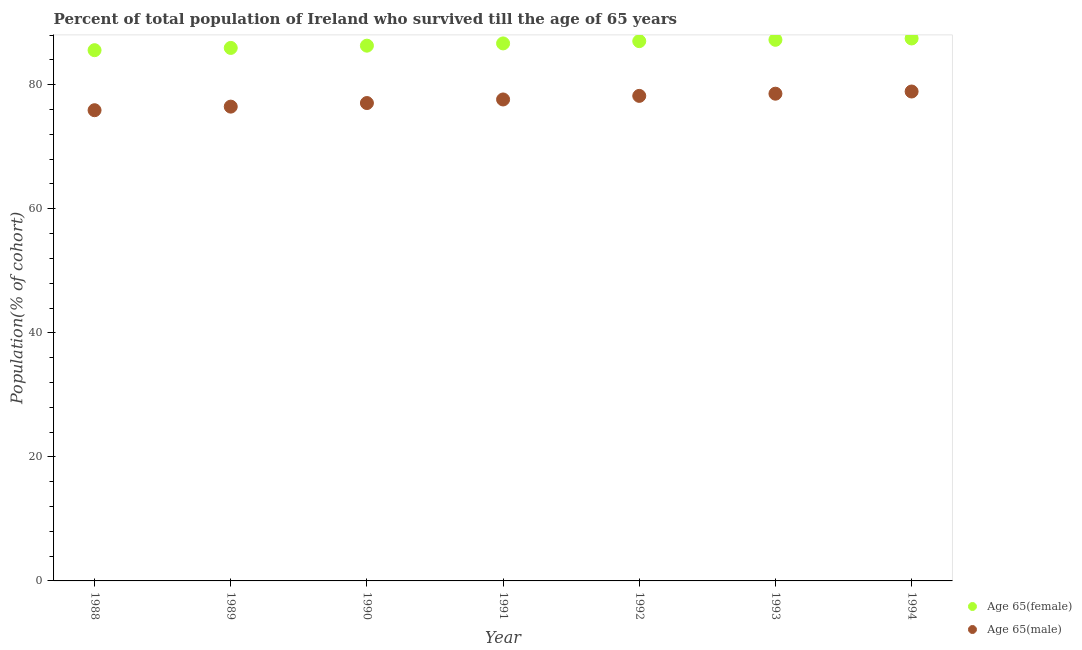How many different coloured dotlines are there?
Ensure brevity in your answer.  2. What is the percentage of male population who survived till age of 65 in 1991?
Provide a succinct answer. 77.62. Across all years, what is the maximum percentage of male population who survived till age of 65?
Provide a succinct answer. 78.9. Across all years, what is the minimum percentage of female population who survived till age of 65?
Keep it short and to the point. 85.57. In which year was the percentage of female population who survived till age of 65 maximum?
Make the answer very short. 1994. What is the total percentage of female population who survived till age of 65 in the graph?
Provide a short and direct response. 606.17. What is the difference between the percentage of female population who survived till age of 65 in 1988 and that in 1993?
Give a very brief answer. -1.67. What is the difference between the percentage of female population who survived till age of 65 in 1990 and the percentage of male population who survived till age of 65 in 1991?
Ensure brevity in your answer.  8.67. What is the average percentage of female population who survived till age of 65 per year?
Offer a terse response. 86.6. In the year 1989, what is the difference between the percentage of female population who survived till age of 65 and percentage of male population who survived till age of 65?
Your answer should be compact. 9.46. In how many years, is the percentage of female population who survived till age of 65 greater than 16 %?
Keep it short and to the point. 7. What is the ratio of the percentage of female population who survived till age of 65 in 1993 to that in 1994?
Ensure brevity in your answer.  1. What is the difference between the highest and the second highest percentage of female population who survived till age of 65?
Give a very brief answer. 0.22. What is the difference between the highest and the lowest percentage of male population who survived till age of 65?
Make the answer very short. 3.02. In how many years, is the percentage of male population who survived till age of 65 greater than the average percentage of male population who survived till age of 65 taken over all years?
Your answer should be compact. 4. Does the percentage of male population who survived till age of 65 monotonically increase over the years?
Make the answer very short. Yes. Is the percentage of female population who survived till age of 65 strictly less than the percentage of male population who survived till age of 65 over the years?
Make the answer very short. No. How many years are there in the graph?
Your response must be concise. 7. Does the graph contain any zero values?
Offer a terse response. No. Where does the legend appear in the graph?
Give a very brief answer. Bottom right. How many legend labels are there?
Give a very brief answer. 2. How are the legend labels stacked?
Your answer should be compact. Vertical. What is the title of the graph?
Your answer should be very brief. Percent of total population of Ireland who survived till the age of 65 years. What is the label or title of the Y-axis?
Ensure brevity in your answer.  Population(% of cohort). What is the Population(% of cohort) of Age 65(female) in 1988?
Make the answer very short. 85.57. What is the Population(% of cohort) in Age 65(male) in 1988?
Keep it short and to the point. 75.89. What is the Population(% of cohort) of Age 65(female) in 1989?
Ensure brevity in your answer.  85.93. What is the Population(% of cohort) of Age 65(male) in 1989?
Your answer should be very brief. 76.47. What is the Population(% of cohort) of Age 65(female) in 1990?
Offer a terse response. 86.29. What is the Population(% of cohort) of Age 65(male) in 1990?
Give a very brief answer. 77.04. What is the Population(% of cohort) in Age 65(female) in 1991?
Your answer should be compact. 86.66. What is the Population(% of cohort) of Age 65(male) in 1991?
Provide a short and direct response. 77.62. What is the Population(% of cohort) in Age 65(female) in 1992?
Provide a short and direct response. 87.02. What is the Population(% of cohort) in Age 65(male) in 1992?
Your response must be concise. 78.2. What is the Population(% of cohort) in Age 65(female) in 1993?
Offer a terse response. 87.24. What is the Population(% of cohort) of Age 65(male) in 1993?
Give a very brief answer. 78.55. What is the Population(% of cohort) in Age 65(female) in 1994?
Your answer should be compact. 87.46. What is the Population(% of cohort) in Age 65(male) in 1994?
Keep it short and to the point. 78.9. Across all years, what is the maximum Population(% of cohort) in Age 65(female)?
Offer a very short reply. 87.46. Across all years, what is the maximum Population(% of cohort) in Age 65(male)?
Offer a terse response. 78.9. Across all years, what is the minimum Population(% of cohort) of Age 65(female)?
Provide a succinct answer. 85.57. Across all years, what is the minimum Population(% of cohort) in Age 65(male)?
Provide a succinct answer. 75.89. What is the total Population(% of cohort) in Age 65(female) in the graph?
Offer a terse response. 606.17. What is the total Population(% of cohort) in Age 65(male) in the graph?
Your response must be concise. 542.67. What is the difference between the Population(% of cohort) in Age 65(female) in 1988 and that in 1989?
Your answer should be compact. -0.36. What is the difference between the Population(% of cohort) in Age 65(male) in 1988 and that in 1989?
Offer a very short reply. -0.58. What is the difference between the Population(% of cohort) of Age 65(female) in 1988 and that in 1990?
Provide a succinct answer. -0.73. What is the difference between the Population(% of cohort) in Age 65(male) in 1988 and that in 1990?
Provide a short and direct response. -1.16. What is the difference between the Population(% of cohort) of Age 65(female) in 1988 and that in 1991?
Offer a terse response. -1.09. What is the difference between the Population(% of cohort) of Age 65(male) in 1988 and that in 1991?
Keep it short and to the point. -1.73. What is the difference between the Population(% of cohort) of Age 65(female) in 1988 and that in 1992?
Give a very brief answer. -1.46. What is the difference between the Population(% of cohort) in Age 65(male) in 1988 and that in 1992?
Offer a terse response. -2.31. What is the difference between the Population(% of cohort) of Age 65(female) in 1988 and that in 1993?
Your answer should be very brief. -1.67. What is the difference between the Population(% of cohort) in Age 65(male) in 1988 and that in 1993?
Offer a very short reply. -2.66. What is the difference between the Population(% of cohort) of Age 65(female) in 1988 and that in 1994?
Provide a succinct answer. -1.89. What is the difference between the Population(% of cohort) in Age 65(male) in 1988 and that in 1994?
Give a very brief answer. -3.02. What is the difference between the Population(% of cohort) of Age 65(female) in 1989 and that in 1990?
Your response must be concise. -0.36. What is the difference between the Population(% of cohort) in Age 65(male) in 1989 and that in 1990?
Ensure brevity in your answer.  -0.58. What is the difference between the Population(% of cohort) of Age 65(female) in 1989 and that in 1991?
Your answer should be compact. -0.73. What is the difference between the Population(% of cohort) of Age 65(male) in 1989 and that in 1991?
Your response must be concise. -1.16. What is the difference between the Population(% of cohort) in Age 65(female) in 1989 and that in 1992?
Your answer should be compact. -1.09. What is the difference between the Population(% of cohort) of Age 65(male) in 1989 and that in 1992?
Offer a terse response. -1.73. What is the difference between the Population(% of cohort) in Age 65(female) in 1989 and that in 1993?
Offer a terse response. -1.31. What is the difference between the Population(% of cohort) in Age 65(male) in 1989 and that in 1993?
Make the answer very short. -2.09. What is the difference between the Population(% of cohort) in Age 65(female) in 1989 and that in 1994?
Your answer should be compact. -1.53. What is the difference between the Population(% of cohort) of Age 65(male) in 1989 and that in 1994?
Ensure brevity in your answer.  -2.44. What is the difference between the Population(% of cohort) in Age 65(female) in 1990 and that in 1991?
Keep it short and to the point. -0.36. What is the difference between the Population(% of cohort) in Age 65(male) in 1990 and that in 1991?
Make the answer very short. -0.58. What is the difference between the Population(% of cohort) in Age 65(female) in 1990 and that in 1992?
Your answer should be very brief. -0.73. What is the difference between the Population(% of cohort) of Age 65(male) in 1990 and that in 1992?
Your answer should be compact. -1.16. What is the difference between the Population(% of cohort) of Age 65(female) in 1990 and that in 1993?
Give a very brief answer. -0.94. What is the difference between the Population(% of cohort) of Age 65(male) in 1990 and that in 1993?
Your answer should be very brief. -1.51. What is the difference between the Population(% of cohort) in Age 65(female) in 1990 and that in 1994?
Your answer should be very brief. -1.16. What is the difference between the Population(% of cohort) in Age 65(male) in 1990 and that in 1994?
Your answer should be very brief. -1.86. What is the difference between the Population(% of cohort) in Age 65(female) in 1991 and that in 1992?
Ensure brevity in your answer.  -0.36. What is the difference between the Population(% of cohort) of Age 65(male) in 1991 and that in 1992?
Your answer should be compact. -0.58. What is the difference between the Population(% of cohort) in Age 65(female) in 1991 and that in 1993?
Keep it short and to the point. -0.58. What is the difference between the Population(% of cohort) in Age 65(male) in 1991 and that in 1993?
Provide a succinct answer. -0.93. What is the difference between the Population(% of cohort) in Age 65(female) in 1991 and that in 1994?
Provide a short and direct response. -0.8. What is the difference between the Population(% of cohort) in Age 65(male) in 1991 and that in 1994?
Provide a short and direct response. -1.28. What is the difference between the Population(% of cohort) in Age 65(female) in 1992 and that in 1993?
Offer a terse response. -0.22. What is the difference between the Population(% of cohort) of Age 65(male) in 1992 and that in 1993?
Offer a terse response. -0.35. What is the difference between the Population(% of cohort) in Age 65(female) in 1992 and that in 1994?
Offer a terse response. -0.43. What is the difference between the Population(% of cohort) of Age 65(male) in 1992 and that in 1994?
Ensure brevity in your answer.  -0.71. What is the difference between the Population(% of cohort) of Age 65(female) in 1993 and that in 1994?
Give a very brief answer. -0.22. What is the difference between the Population(% of cohort) in Age 65(male) in 1993 and that in 1994?
Give a very brief answer. -0.35. What is the difference between the Population(% of cohort) of Age 65(female) in 1988 and the Population(% of cohort) of Age 65(male) in 1989?
Keep it short and to the point. 9.1. What is the difference between the Population(% of cohort) of Age 65(female) in 1988 and the Population(% of cohort) of Age 65(male) in 1990?
Your answer should be compact. 8.52. What is the difference between the Population(% of cohort) in Age 65(female) in 1988 and the Population(% of cohort) in Age 65(male) in 1991?
Provide a short and direct response. 7.95. What is the difference between the Population(% of cohort) of Age 65(female) in 1988 and the Population(% of cohort) of Age 65(male) in 1992?
Your answer should be very brief. 7.37. What is the difference between the Population(% of cohort) of Age 65(female) in 1988 and the Population(% of cohort) of Age 65(male) in 1993?
Offer a very short reply. 7.02. What is the difference between the Population(% of cohort) of Age 65(female) in 1988 and the Population(% of cohort) of Age 65(male) in 1994?
Your answer should be very brief. 6.66. What is the difference between the Population(% of cohort) in Age 65(female) in 1989 and the Population(% of cohort) in Age 65(male) in 1990?
Your answer should be very brief. 8.89. What is the difference between the Population(% of cohort) in Age 65(female) in 1989 and the Population(% of cohort) in Age 65(male) in 1991?
Offer a very short reply. 8.31. What is the difference between the Population(% of cohort) in Age 65(female) in 1989 and the Population(% of cohort) in Age 65(male) in 1992?
Make the answer very short. 7.73. What is the difference between the Population(% of cohort) in Age 65(female) in 1989 and the Population(% of cohort) in Age 65(male) in 1993?
Your answer should be compact. 7.38. What is the difference between the Population(% of cohort) in Age 65(female) in 1989 and the Population(% of cohort) in Age 65(male) in 1994?
Your answer should be very brief. 7.03. What is the difference between the Population(% of cohort) in Age 65(female) in 1990 and the Population(% of cohort) in Age 65(male) in 1991?
Provide a succinct answer. 8.67. What is the difference between the Population(% of cohort) of Age 65(female) in 1990 and the Population(% of cohort) of Age 65(male) in 1992?
Offer a terse response. 8.1. What is the difference between the Population(% of cohort) of Age 65(female) in 1990 and the Population(% of cohort) of Age 65(male) in 1993?
Your response must be concise. 7.74. What is the difference between the Population(% of cohort) in Age 65(female) in 1990 and the Population(% of cohort) in Age 65(male) in 1994?
Keep it short and to the point. 7.39. What is the difference between the Population(% of cohort) of Age 65(female) in 1991 and the Population(% of cohort) of Age 65(male) in 1992?
Your answer should be very brief. 8.46. What is the difference between the Population(% of cohort) in Age 65(female) in 1991 and the Population(% of cohort) in Age 65(male) in 1993?
Offer a terse response. 8.11. What is the difference between the Population(% of cohort) in Age 65(female) in 1991 and the Population(% of cohort) in Age 65(male) in 1994?
Your answer should be compact. 7.75. What is the difference between the Population(% of cohort) of Age 65(female) in 1992 and the Population(% of cohort) of Age 65(male) in 1993?
Your answer should be very brief. 8.47. What is the difference between the Population(% of cohort) in Age 65(female) in 1992 and the Population(% of cohort) in Age 65(male) in 1994?
Offer a very short reply. 8.12. What is the difference between the Population(% of cohort) of Age 65(female) in 1993 and the Population(% of cohort) of Age 65(male) in 1994?
Make the answer very short. 8.34. What is the average Population(% of cohort) in Age 65(female) per year?
Your answer should be very brief. 86.6. What is the average Population(% of cohort) of Age 65(male) per year?
Provide a short and direct response. 77.52. In the year 1988, what is the difference between the Population(% of cohort) in Age 65(female) and Population(% of cohort) in Age 65(male)?
Your answer should be compact. 9.68. In the year 1989, what is the difference between the Population(% of cohort) in Age 65(female) and Population(% of cohort) in Age 65(male)?
Your answer should be very brief. 9.46. In the year 1990, what is the difference between the Population(% of cohort) in Age 65(female) and Population(% of cohort) in Age 65(male)?
Provide a short and direct response. 9.25. In the year 1991, what is the difference between the Population(% of cohort) in Age 65(female) and Population(% of cohort) in Age 65(male)?
Ensure brevity in your answer.  9.04. In the year 1992, what is the difference between the Population(% of cohort) of Age 65(female) and Population(% of cohort) of Age 65(male)?
Give a very brief answer. 8.82. In the year 1993, what is the difference between the Population(% of cohort) in Age 65(female) and Population(% of cohort) in Age 65(male)?
Ensure brevity in your answer.  8.69. In the year 1994, what is the difference between the Population(% of cohort) of Age 65(female) and Population(% of cohort) of Age 65(male)?
Make the answer very short. 8.55. What is the ratio of the Population(% of cohort) in Age 65(female) in 1988 to that in 1989?
Offer a very short reply. 1. What is the ratio of the Population(% of cohort) in Age 65(male) in 1988 to that in 1989?
Your answer should be very brief. 0.99. What is the ratio of the Population(% of cohort) in Age 65(male) in 1988 to that in 1990?
Give a very brief answer. 0.98. What is the ratio of the Population(% of cohort) of Age 65(female) in 1988 to that in 1991?
Offer a terse response. 0.99. What is the ratio of the Population(% of cohort) of Age 65(male) in 1988 to that in 1991?
Your answer should be compact. 0.98. What is the ratio of the Population(% of cohort) in Age 65(female) in 1988 to that in 1992?
Your answer should be very brief. 0.98. What is the ratio of the Population(% of cohort) in Age 65(male) in 1988 to that in 1992?
Give a very brief answer. 0.97. What is the ratio of the Population(% of cohort) in Age 65(female) in 1988 to that in 1993?
Offer a very short reply. 0.98. What is the ratio of the Population(% of cohort) of Age 65(male) in 1988 to that in 1993?
Offer a very short reply. 0.97. What is the ratio of the Population(% of cohort) in Age 65(female) in 1988 to that in 1994?
Your answer should be very brief. 0.98. What is the ratio of the Population(% of cohort) of Age 65(male) in 1988 to that in 1994?
Provide a short and direct response. 0.96. What is the ratio of the Population(% of cohort) of Age 65(female) in 1989 to that in 1990?
Offer a very short reply. 1. What is the ratio of the Population(% of cohort) of Age 65(female) in 1989 to that in 1991?
Make the answer very short. 0.99. What is the ratio of the Population(% of cohort) of Age 65(male) in 1989 to that in 1991?
Offer a terse response. 0.99. What is the ratio of the Population(% of cohort) of Age 65(female) in 1989 to that in 1992?
Provide a succinct answer. 0.99. What is the ratio of the Population(% of cohort) in Age 65(male) in 1989 to that in 1992?
Keep it short and to the point. 0.98. What is the ratio of the Population(% of cohort) in Age 65(male) in 1989 to that in 1993?
Your response must be concise. 0.97. What is the ratio of the Population(% of cohort) of Age 65(female) in 1989 to that in 1994?
Offer a terse response. 0.98. What is the ratio of the Population(% of cohort) of Age 65(male) in 1989 to that in 1994?
Offer a very short reply. 0.97. What is the ratio of the Population(% of cohort) in Age 65(female) in 1990 to that in 1991?
Make the answer very short. 1. What is the ratio of the Population(% of cohort) of Age 65(male) in 1990 to that in 1991?
Offer a very short reply. 0.99. What is the ratio of the Population(% of cohort) of Age 65(male) in 1990 to that in 1992?
Your response must be concise. 0.99. What is the ratio of the Population(% of cohort) of Age 65(male) in 1990 to that in 1993?
Provide a succinct answer. 0.98. What is the ratio of the Population(% of cohort) of Age 65(female) in 1990 to that in 1994?
Give a very brief answer. 0.99. What is the ratio of the Population(% of cohort) in Age 65(male) in 1990 to that in 1994?
Ensure brevity in your answer.  0.98. What is the ratio of the Population(% of cohort) of Age 65(female) in 1991 to that in 1993?
Provide a short and direct response. 0.99. What is the ratio of the Population(% of cohort) in Age 65(female) in 1991 to that in 1994?
Your answer should be compact. 0.99. What is the ratio of the Population(% of cohort) in Age 65(male) in 1991 to that in 1994?
Your response must be concise. 0.98. What is the ratio of the Population(% of cohort) of Age 65(female) in 1992 to that in 1993?
Your answer should be compact. 1. What is the ratio of the Population(% of cohort) in Age 65(male) in 1992 to that in 1993?
Ensure brevity in your answer.  1. What is the ratio of the Population(% of cohort) of Age 65(female) in 1992 to that in 1994?
Offer a very short reply. 0.99. What is the ratio of the Population(% of cohort) of Age 65(male) in 1992 to that in 1994?
Ensure brevity in your answer.  0.99. What is the ratio of the Population(% of cohort) in Age 65(female) in 1993 to that in 1994?
Your answer should be compact. 1. What is the difference between the highest and the second highest Population(% of cohort) in Age 65(female)?
Offer a very short reply. 0.22. What is the difference between the highest and the second highest Population(% of cohort) in Age 65(male)?
Keep it short and to the point. 0.35. What is the difference between the highest and the lowest Population(% of cohort) of Age 65(female)?
Make the answer very short. 1.89. What is the difference between the highest and the lowest Population(% of cohort) in Age 65(male)?
Your answer should be compact. 3.02. 